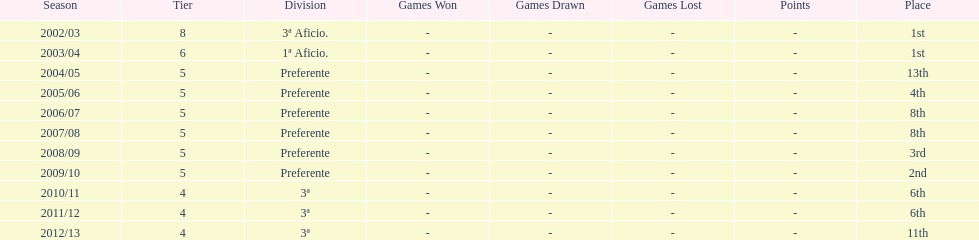Which division placed more than aficio 1a and 3a? Preferente. 